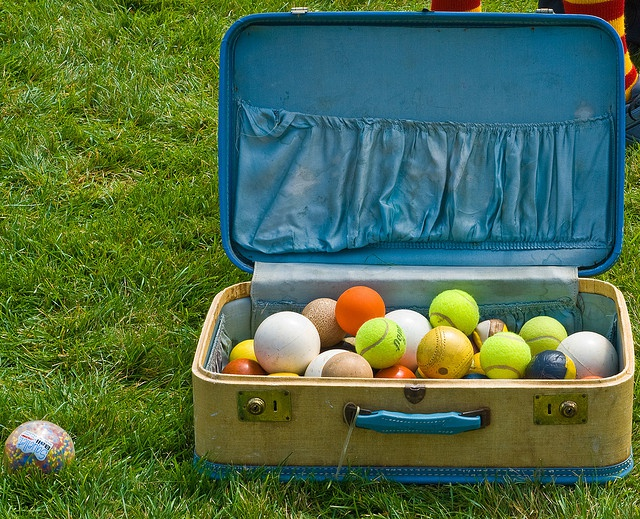Describe the objects in this image and their specific colors. I can see suitcase in olive, teal, and black tones, sports ball in olive, ivory, red, and black tones, sports ball in olive, lightgray, darkgray, tan, and gray tones, sports ball in olive and gold tones, and people in olive, maroon, black, and orange tones in this image. 